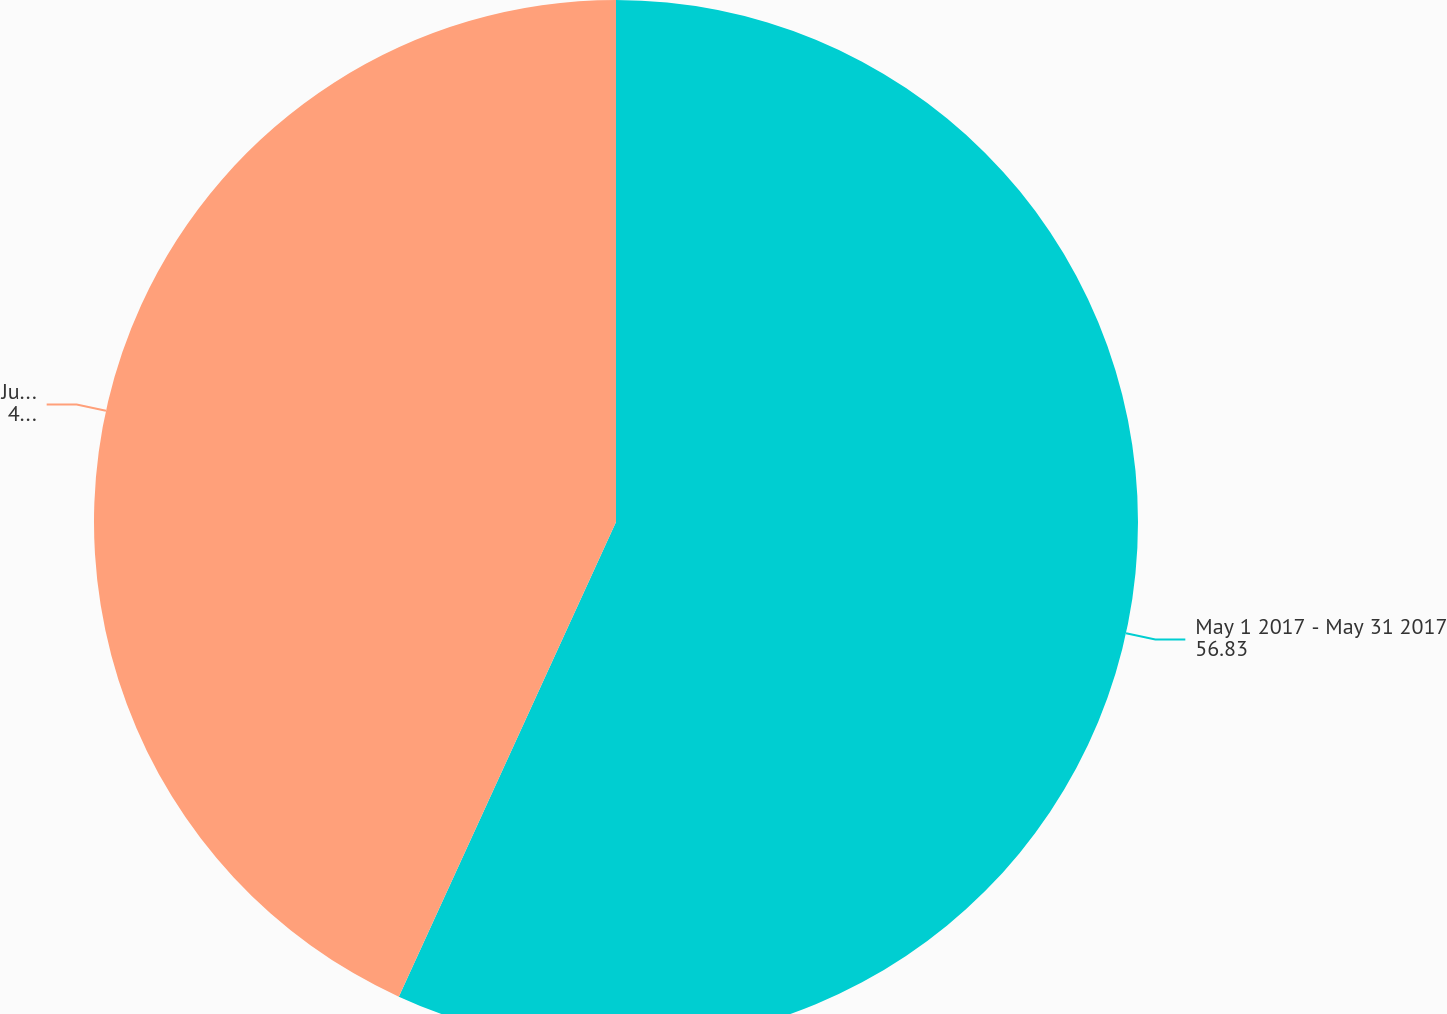Convert chart. <chart><loc_0><loc_0><loc_500><loc_500><pie_chart><fcel>May 1 2017 - May 31 2017<fcel>June 1 2017 - June 30 2017<nl><fcel>56.83%<fcel>43.17%<nl></chart> 